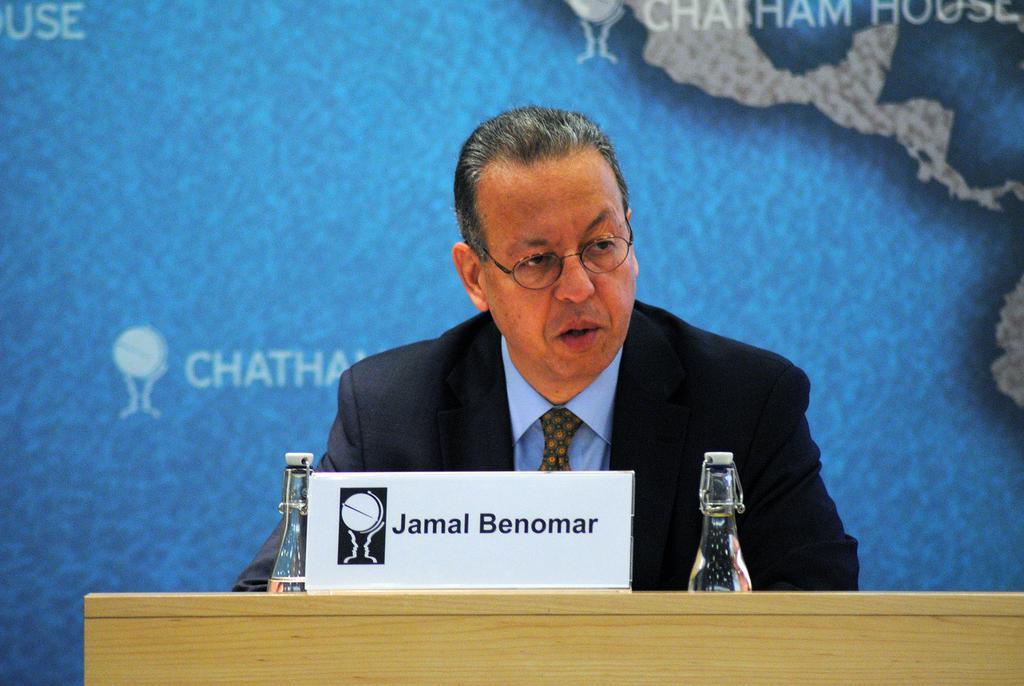In one or two sentences, can you explain what this image depicts? At the bottom of the image there is a table, on the table there are some bottles and banner. Behind the table a person is standing. Behind him there is a banner. 